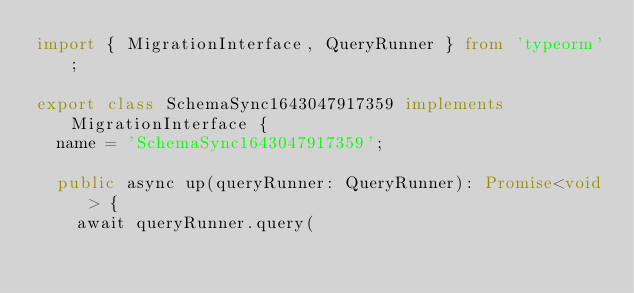<code> <loc_0><loc_0><loc_500><loc_500><_TypeScript_>import { MigrationInterface, QueryRunner } from 'typeorm';

export class SchemaSync1643047917359 implements MigrationInterface {
  name = 'SchemaSync1643047917359';

  public async up(queryRunner: QueryRunner): Promise<void> {
    await queryRunner.query(</code> 